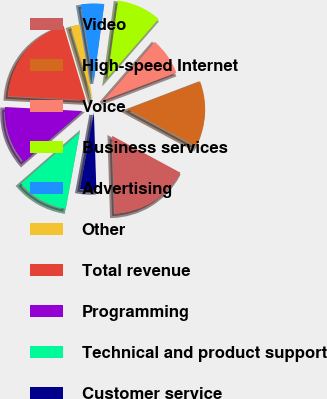Convert chart. <chart><loc_0><loc_0><loc_500><loc_500><pie_chart><fcel>Video<fcel>High-speed Internet<fcel>Voice<fcel>Business services<fcel>Advertising<fcel>Other<fcel>Total revenue<fcel>Programming<fcel>Technical and product support<fcel>Customer service<nl><fcel>16.62%<fcel>13.68%<fcel>7.79%<fcel>9.26%<fcel>4.85%<fcel>1.91%<fcel>19.56%<fcel>12.21%<fcel>10.74%<fcel>3.38%<nl></chart> 